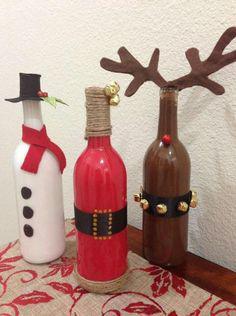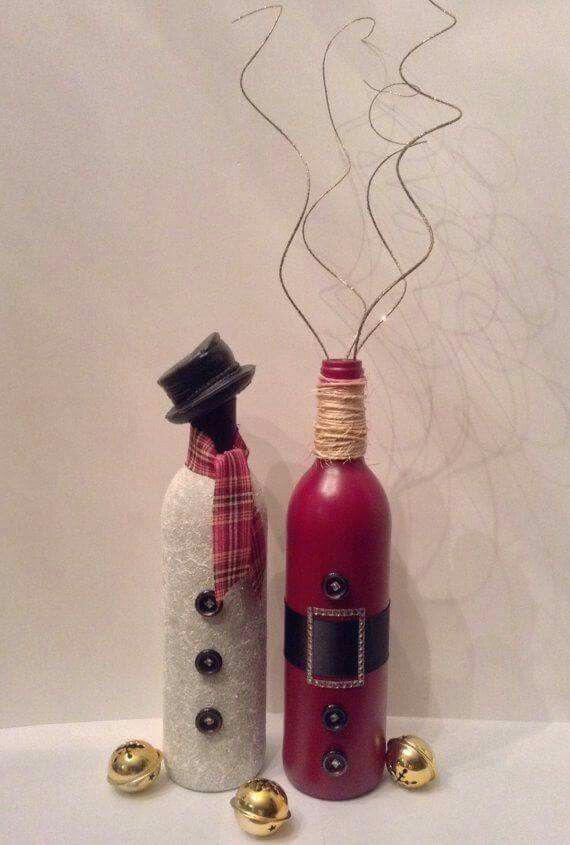The first image is the image on the left, the second image is the image on the right. Given the left and right images, does the statement "All of the bottles look like snowmen." hold true? Answer yes or no. No. 